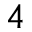Convert formula to latex. <formula><loc_0><loc_0><loc_500><loc_500>^ { 4 }</formula> 